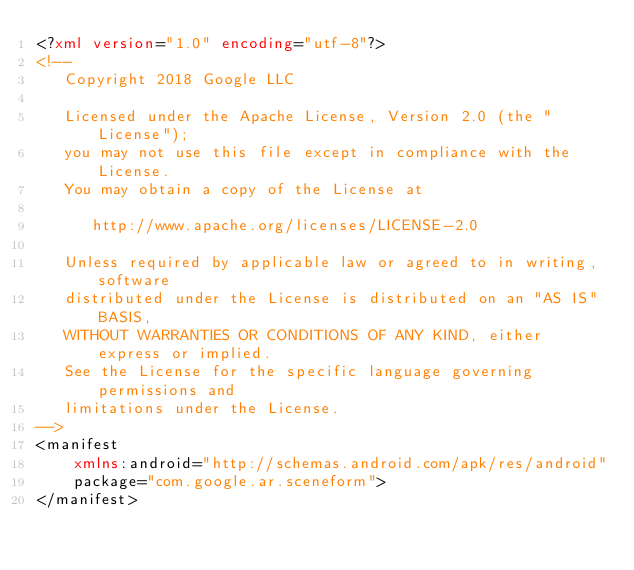<code> <loc_0><loc_0><loc_500><loc_500><_XML_><?xml version="1.0" encoding="utf-8"?>
<!--
   Copyright 2018 Google LLC

   Licensed under the Apache License, Version 2.0 (the "License");
   you may not use this file except in compliance with the License.
   You may obtain a copy of the License at

      http://www.apache.org/licenses/LICENSE-2.0

   Unless required by applicable law or agreed to in writing, software
   distributed under the License is distributed on an "AS IS" BASIS,
   WITHOUT WARRANTIES OR CONDITIONS OF ANY KIND, either express or implied.
   See the License for the specific language governing permissions and
   limitations under the License.
-->
<manifest
    xmlns:android="http://schemas.android.com/apk/res/android"
    package="com.google.ar.sceneform">
</manifest>
</code> 